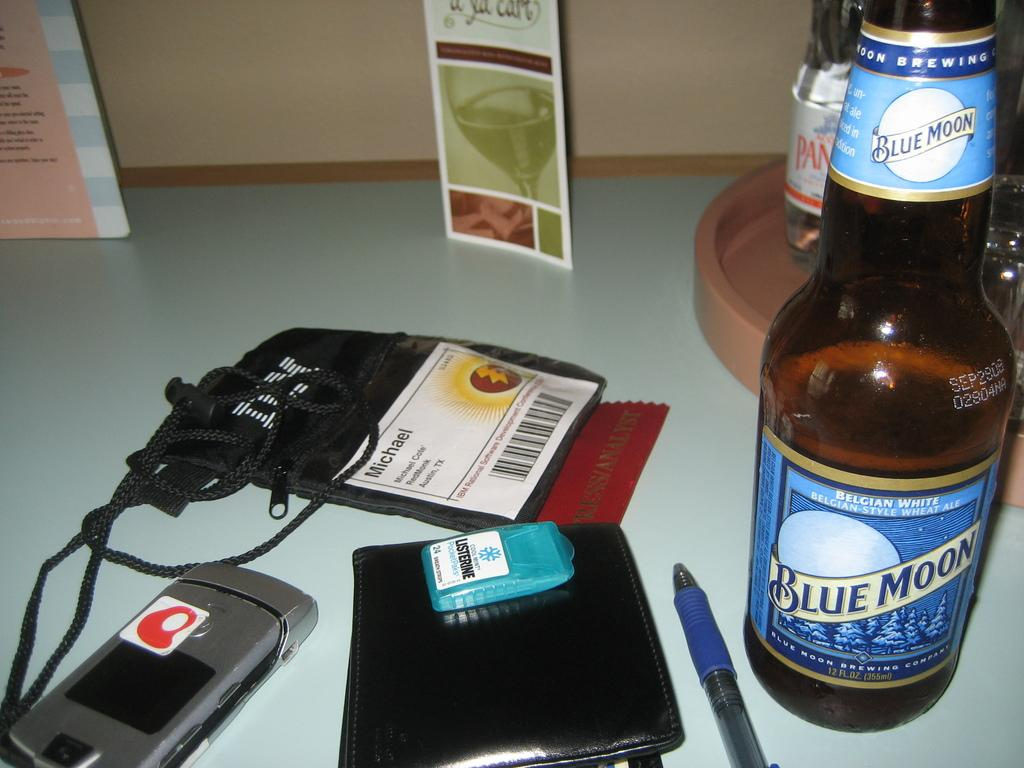<image>
Summarize the visual content of the image. A bottle of Blue Moon beer sits on a desk along with many personal items. 